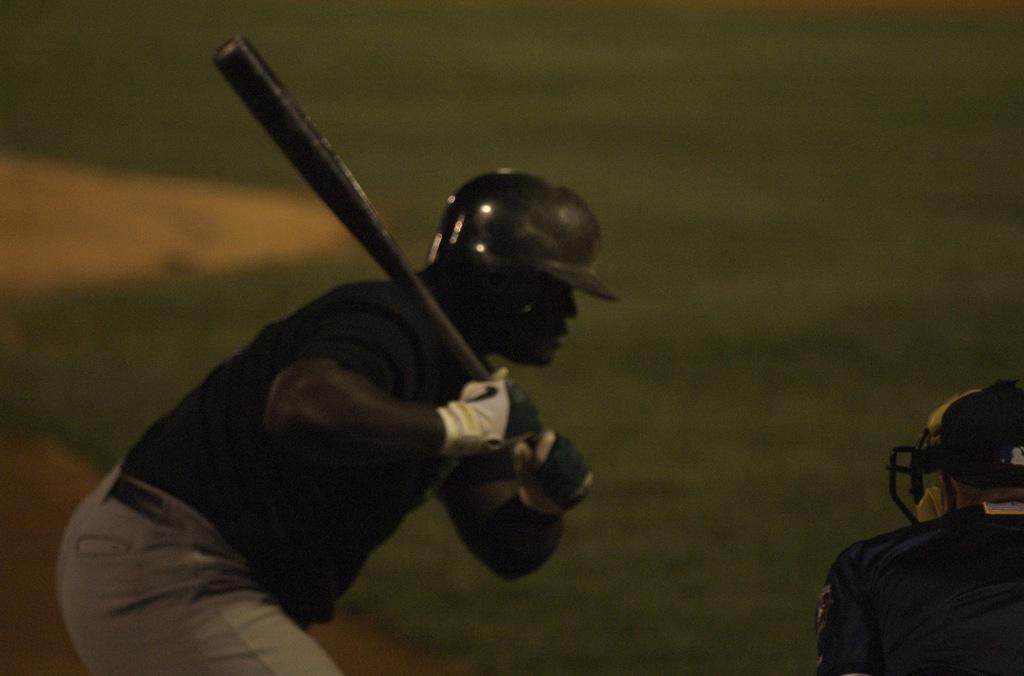How many people are in the foreground of the picture? There are two persons in the foreground of the picture. What is one of the persons holding? One of the persons is holding a bat. What can be seen in the background of the image? The background of the image is black. How many letters are visible on the bikes in the image? There are no bikes present in the image, so there are no letters visible on bikes. 